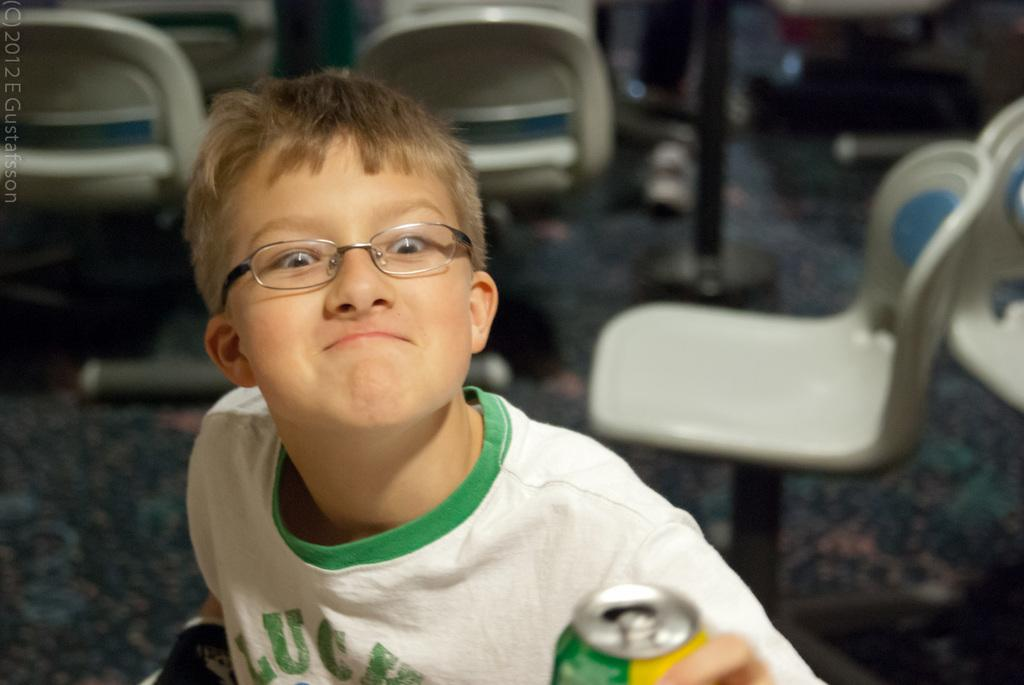What is located on the left side of the image? There is a boy on the left side of the image. What is the boy wearing? The boy is wearing a white T-shirt. What accessory is the boy wearing? The boy is wearing spectacles. What is the boy holding in the image? The boy is holding a tin with one hand. What is the boy doing with the tin? The boy is watching the tin. What can be seen in the background of the image? There are chairs arranged in the background of the image. What type of notebook is the boy using to study earth science in the image? There is no notebook or reference to earth science in the image; it only shows a boy holding a tin and watching it. 